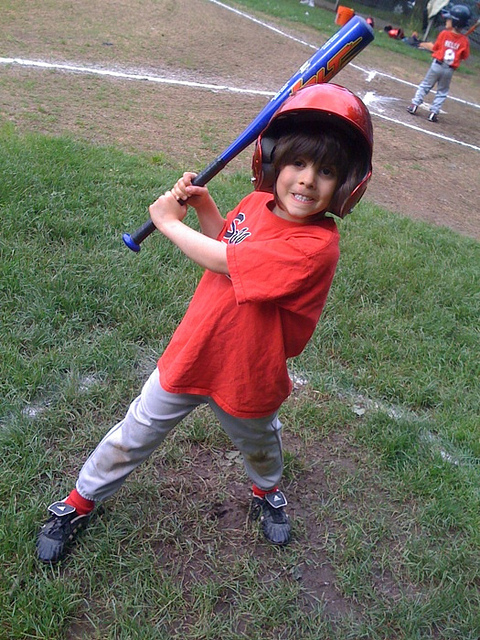Extract all visible text content from this image. Soo 